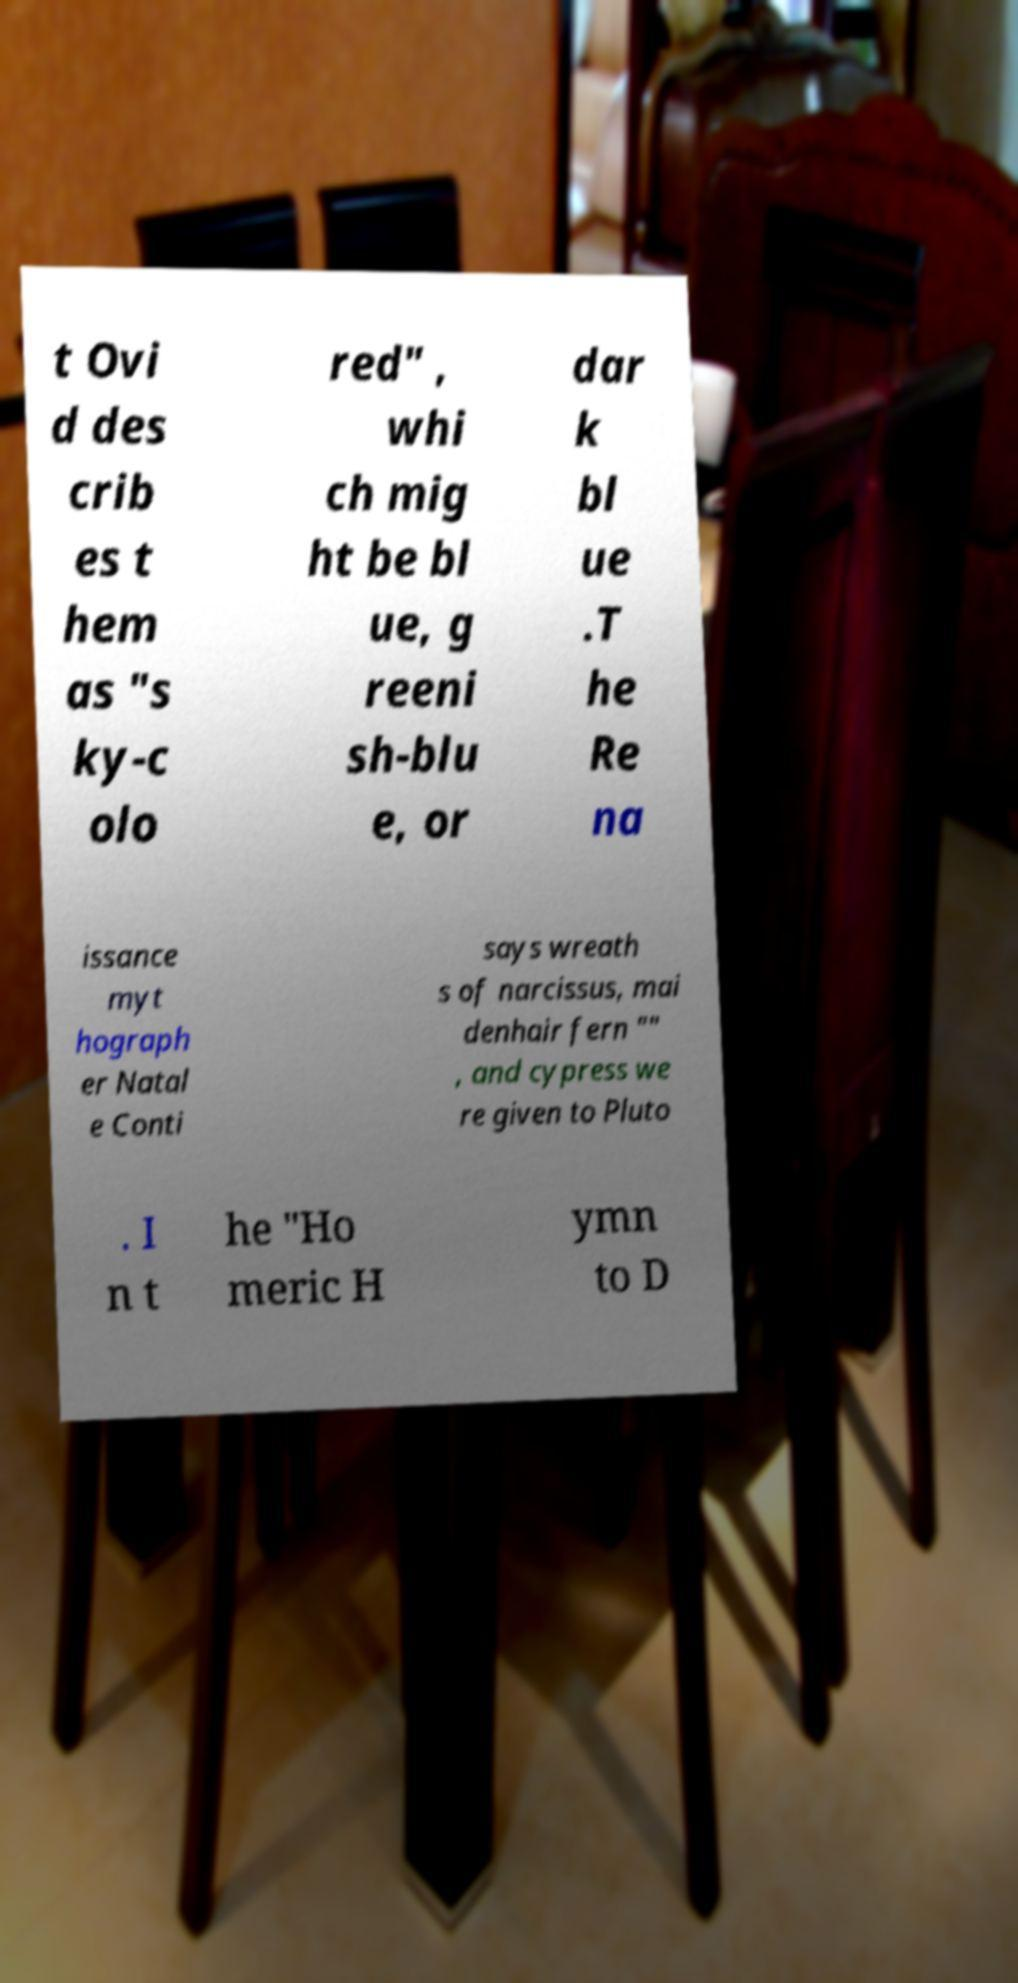Please read and relay the text visible in this image. What does it say? t Ovi d des crib es t hem as "s ky-c olo red" , whi ch mig ht be bl ue, g reeni sh-blu e, or dar k bl ue .T he Re na issance myt hograph er Natal e Conti says wreath s of narcissus, mai denhair fern "" , and cypress we re given to Pluto . I n t he "Ho meric H ymn to D 